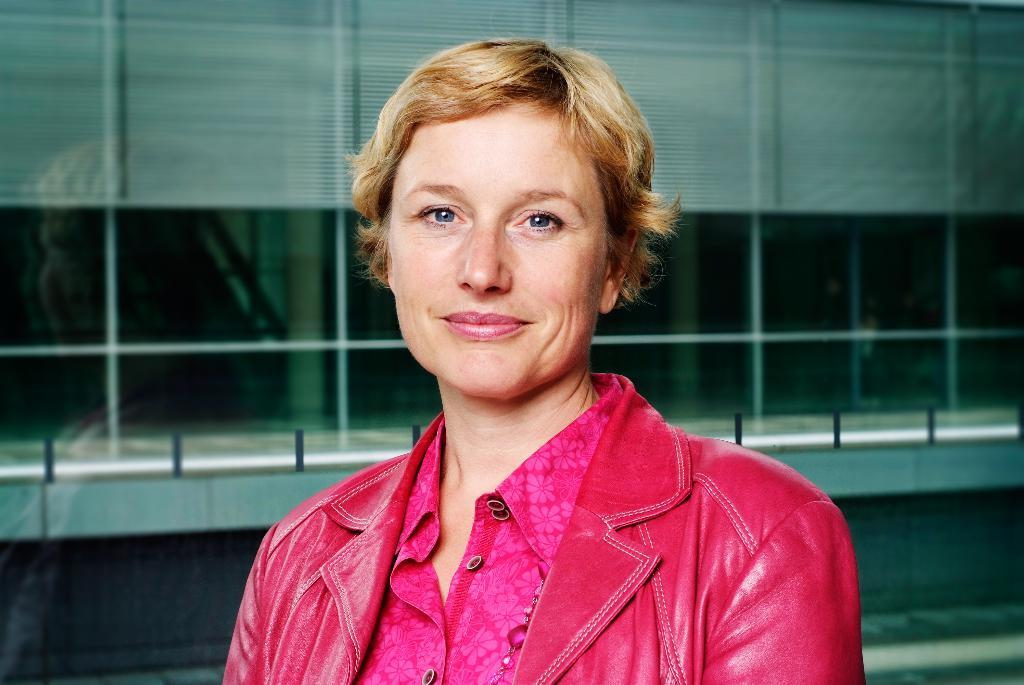Who is the main subject in the picture? There is a woman in the picture. Can you describe the woman's hair in the image? The woman has short hair. What color is the jacket the woman is wearing? The woman is wearing a pink jacket. What expression does the woman have in the image? The woman is smiling. What type of soup is the woman holding in the image? There is no soup present in the image; the woman is not holding anything. 